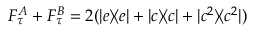Convert formula to latex. <formula><loc_0><loc_0><loc_500><loc_500>F _ { \tau } ^ { A } + F _ { \tau } ^ { B } = 2 ( | e \rangle \, \langle e | + | c \rangle \, \langle c | + | c ^ { 2 } \rangle \, \langle c ^ { 2 } | )</formula> 